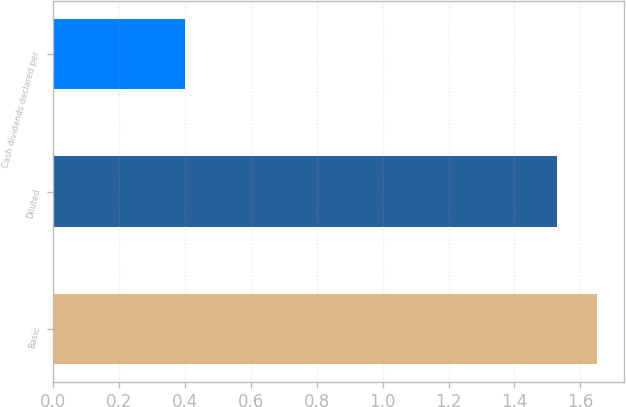<chart> <loc_0><loc_0><loc_500><loc_500><bar_chart><fcel>Basic<fcel>Diluted<fcel>Cash dividends declared per<nl><fcel>1.65<fcel>1.53<fcel>0.4<nl></chart> 